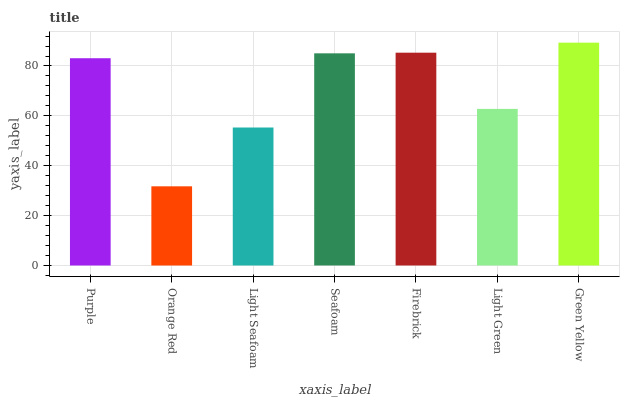Is Orange Red the minimum?
Answer yes or no. Yes. Is Green Yellow the maximum?
Answer yes or no. Yes. Is Light Seafoam the minimum?
Answer yes or no. No. Is Light Seafoam the maximum?
Answer yes or no. No. Is Light Seafoam greater than Orange Red?
Answer yes or no. Yes. Is Orange Red less than Light Seafoam?
Answer yes or no. Yes. Is Orange Red greater than Light Seafoam?
Answer yes or no. No. Is Light Seafoam less than Orange Red?
Answer yes or no. No. Is Purple the high median?
Answer yes or no. Yes. Is Purple the low median?
Answer yes or no. Yes. Is Firebrick the high median?
Answer yes or no. No. Is Firebrick the low median?
Answer yes or no. No. 